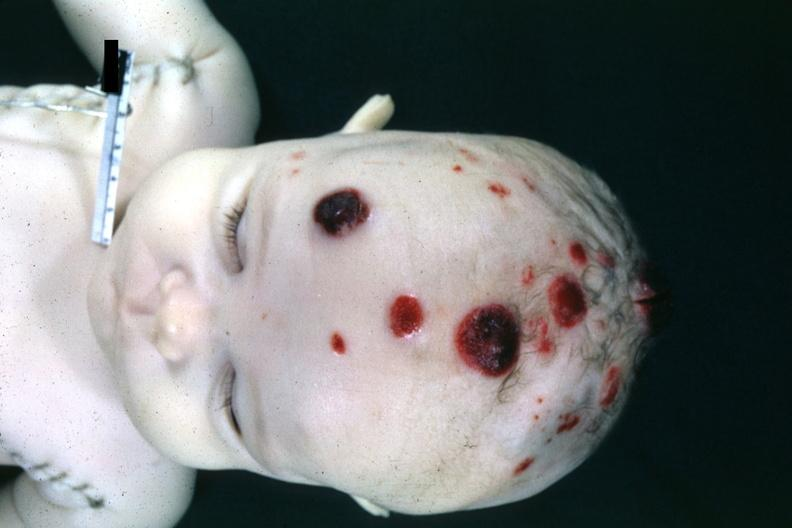what is present?
Answer the question using a single word or phrase. Lymphoblastic lymphoma 